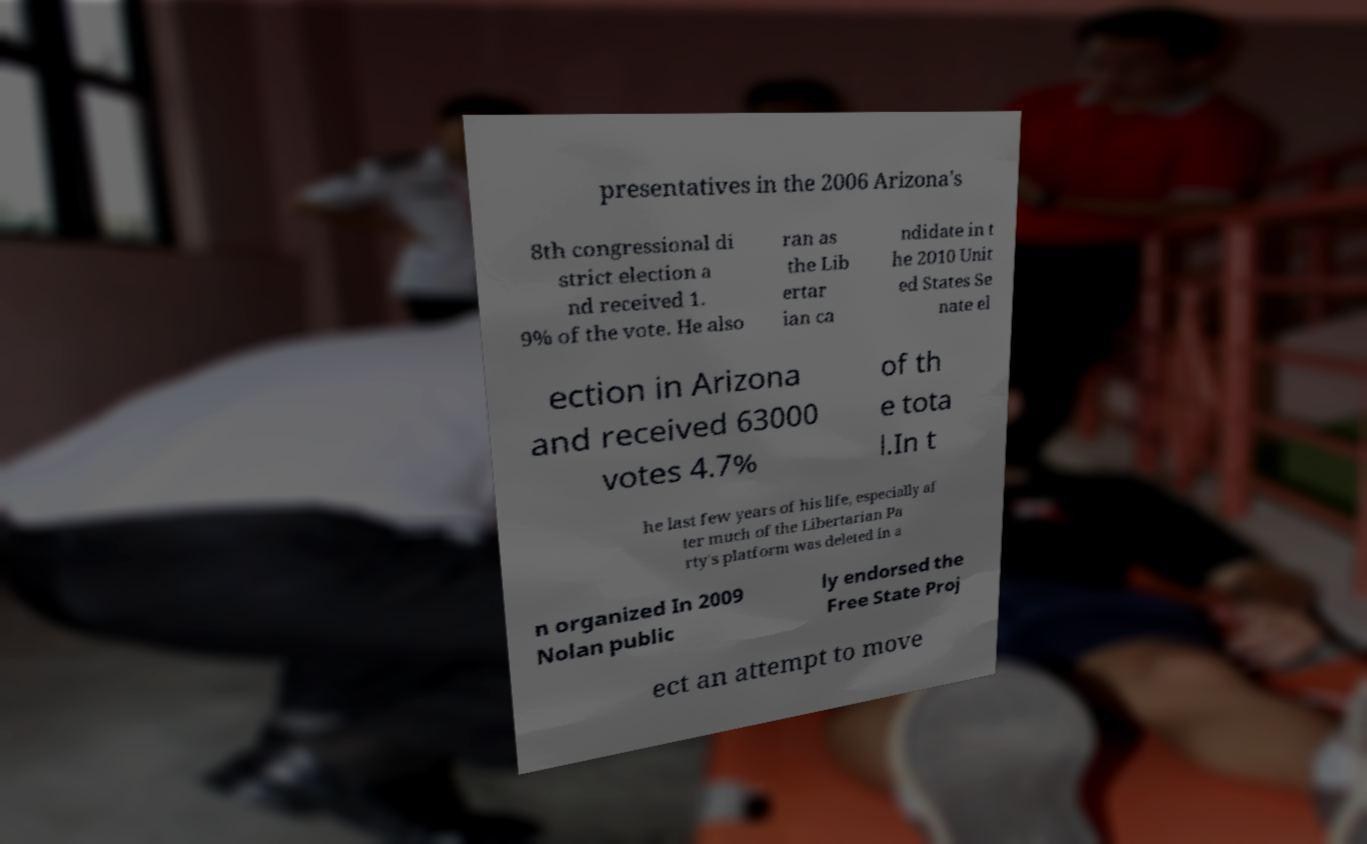Please read and relay the text visible in this image. What does it say? presentatives in the 2006 Arizona's 8th congressional di strict election a nd received 1. 9% of the vote. He also ran as the Lib ertar ian ca ndidate in t he 2010 Unit ed States Se nate el ection in Arizona and received 63000 votes 4.7% of th e tota l.In t he last few years of his life, especially af ter much of the Libertarian Pa rty's platform was deleted in a n organized In 2009 Nolan public ly endorsed the Free State Proj ect an attempt to move 